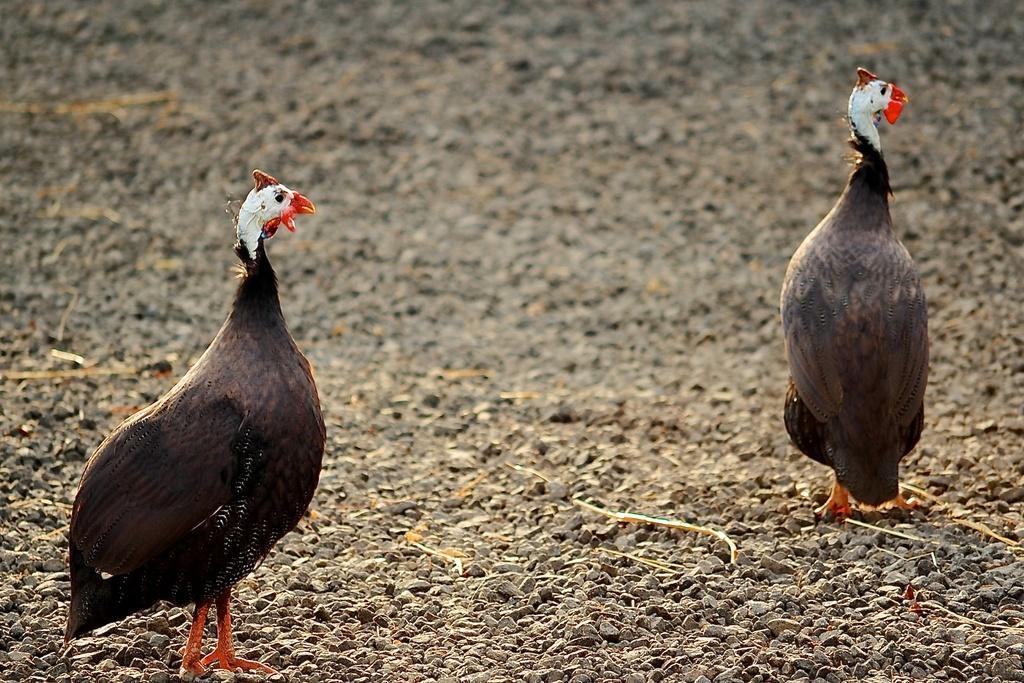How would you summarize this image in a sentence or two? Here we can see two turkey hens standing on the ground and we can also see small stones. 